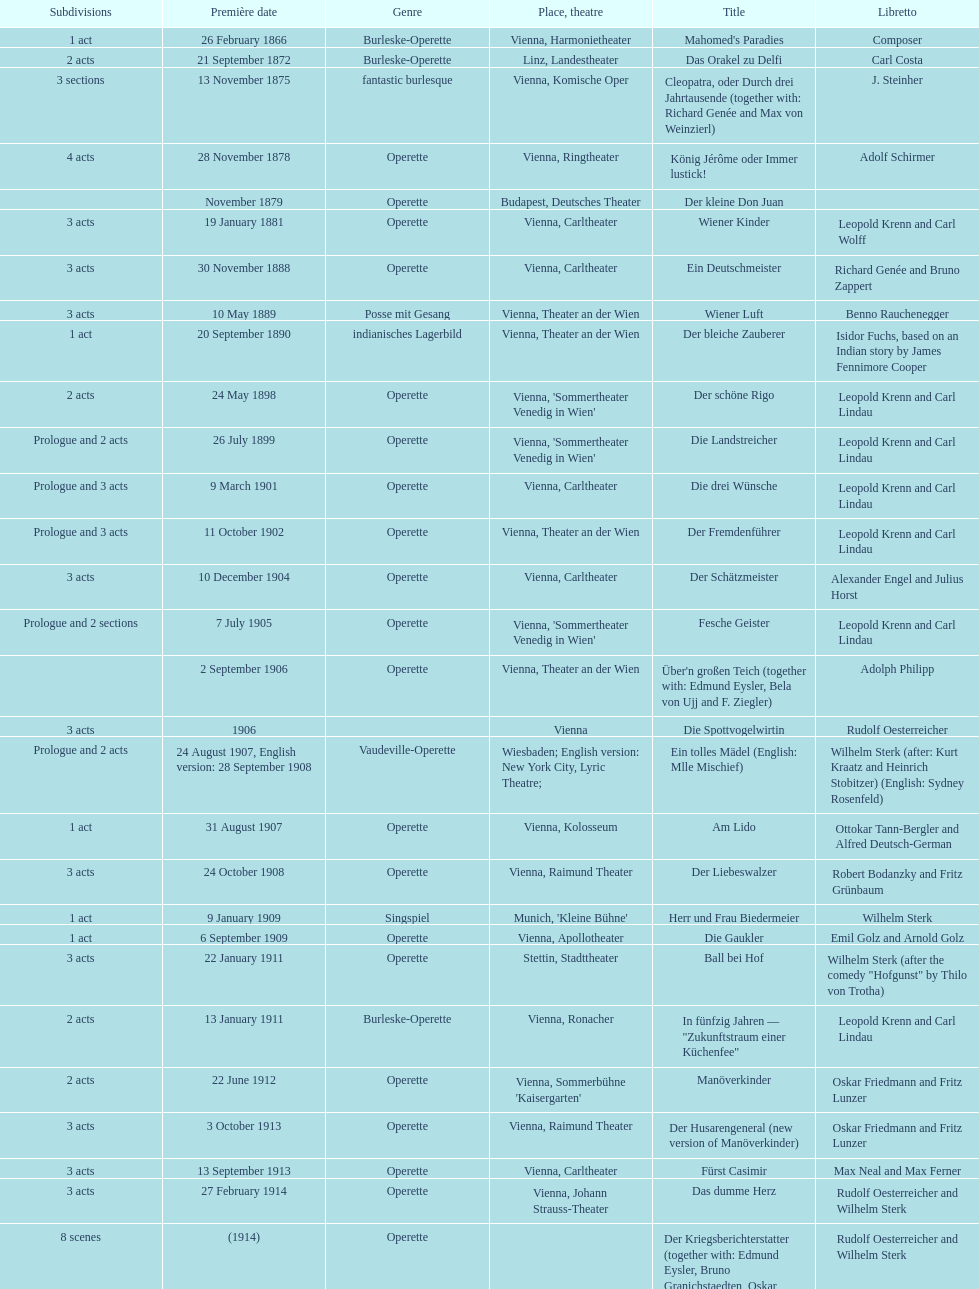What was the year of the most recent championship? 1958. 